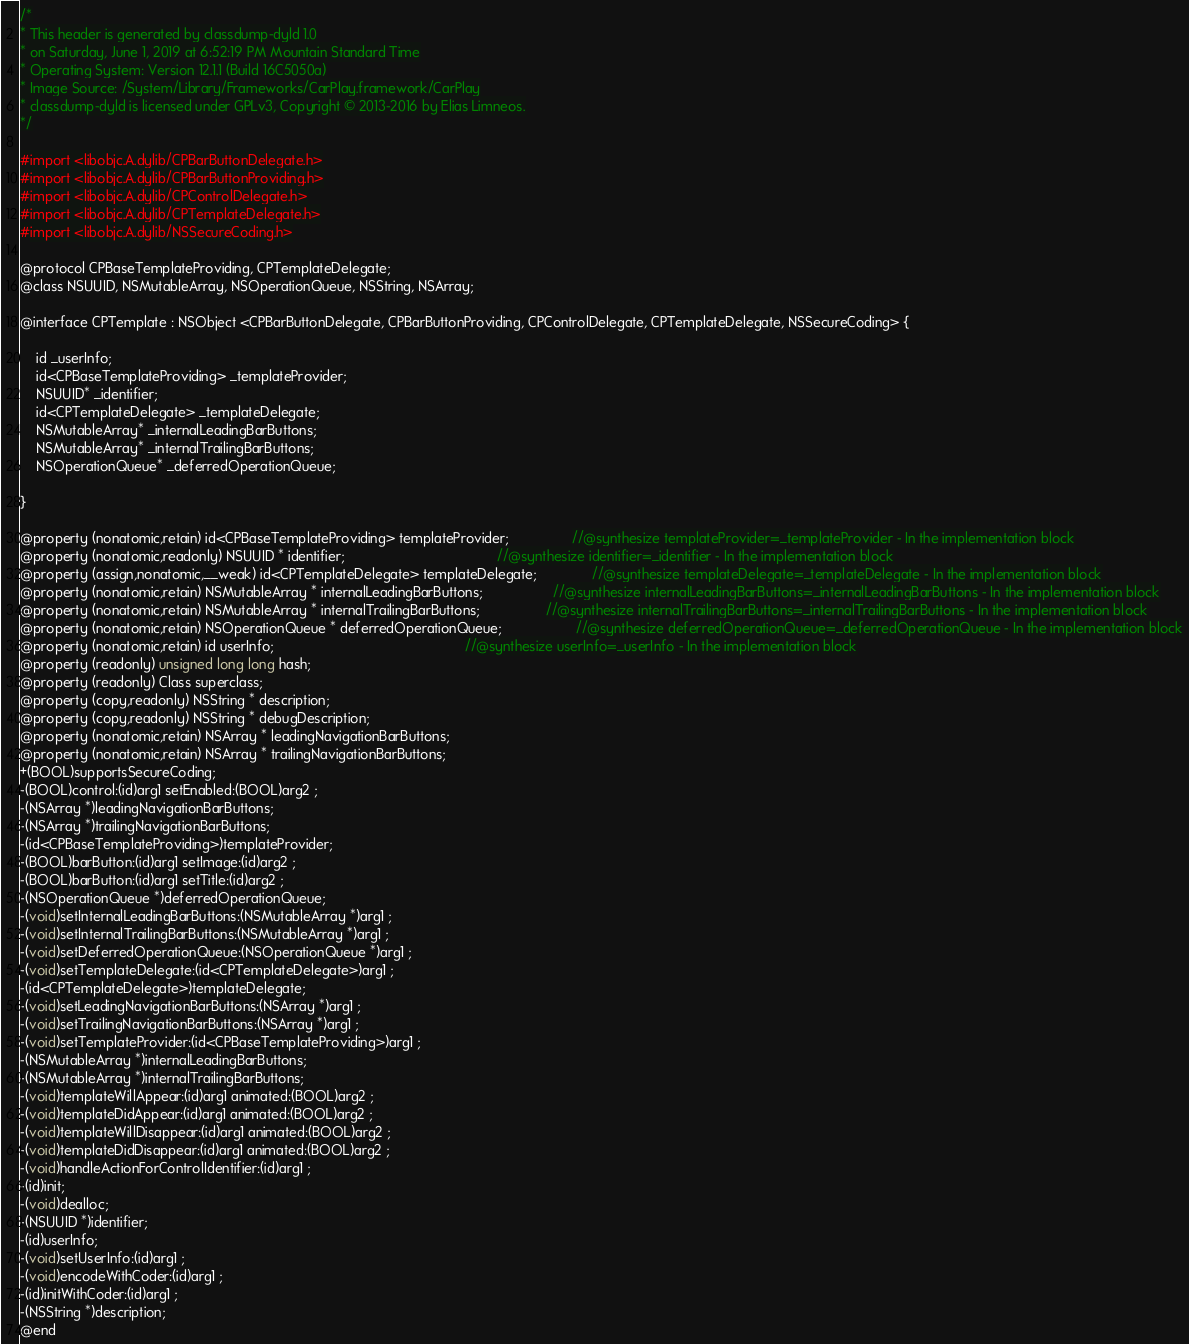Convert code to text. <code><loc_0><loc_0><loc_500><loc_500><_C_>/*
* This header is generated by classdump-dyld 1.0
* on Saturday, June 1, 2019 at 6:52:19 PM Mountain Standard Time
* Operating System: Version 12.1.1 (Build 16C5050a)
* Image Source: /System/Library/Frameworks/CarPlay.framework/CarPlay
* classdump-dyld is licensed under GPLv3, Copyright © 2013-2016 by Elias Limneos.
*/

#import <libobjc.A.dylib/CPBarButtonDelegate.h>
#import <libobjc.A.dylib/CPBarButtonProviding.h>
#import <libobjc.A.dylib/CPControlDelegate.h>
#import <libobjc.A.dylib/CPTemplateDelegate.h>
#import <libobjc.A.dylib/NSSecureCoding.h>

@protocol CPBaseTemplateProviding, CPTemplateDelegate;
@class NSUUID, NSMutableArray, NSOperationQueue, NSString, NSArray;

@interface CPTemplate : NSObject <CPBarButtonDelegate, CPBarButtonProviding, CPControlDelegate, CPTemplateDelegate, NSSecureCoding> {

	id _userInfo;
	id<CPBaseTemplateProviding> _templateProvider;
	NSUUID* _identifier;
	id<CPTemplateDelegate> _templateDelegate;
	NSMutableArray* _internalLeadingBarButtons;
	NSMutableArray* _internalTrailingBarButtons;
	NSOperationQueue* _deferredOperationQueue;

}

@property (nonatomic,retain) id<CPBaseTemplateProviding> templateProvider;                //@synthesize templateProvider=_templateProvider - In the implementation block
@property (nonatomic,readonly) NSUUID * identifier;                                       //@synthesize identifier=_identifier - In the implementation block
@property (assign,nonatomic,__weak) id<CPTemplateDelegate> templateDelegate;              //@synthesize templateDelegate=_templateDelegate - In the implementation block
@property (nonatomic,retain) NSMutableArray * internalLeadingBarButtons;                  //@synthesize internalLeadingBarButtons=_internalLeadingBarButtons - In the implementation block
@property (nonatomic,retain) NSMutableArray * internalTrailingBarButtons;                 //@synthesize internalTrailingBarButtons=_internalTrailingBarButtons - In the implementation block
@property (nonatomic,retain) NSOperationQueue * deferredOperationQueue;                   //@synthesize deferredOperationQueue=_deferredOperationQueue - In the implementation block
@property (nonatomic,retain) id userInfo;                                                 //@synthesize userInfo=_userInfo - In the implementation block
@property (readonly) unsigned long long hash; 
@property (readonly) Class superclass; 
@property (copy,readonly) NSString * description; 
@property (copy,readonly) NSString * debugDescription; 
@property (nonatomic,retain) NSArray * leadingNavigationBarButtons; 
@property (nonatomic,retain) NSArray * trailingNavigationBarButtons; 
+(BOOL)supportsSecureCoding;
-(BOOL)control:(id)arg1 setEnabled:(BOOL)arg2 ;
-(NSArray *)leadingNavigationBarButtons;
-(NSArray *)trailingNavigationBarButtons;
-(id<CPBaseTemplateProviding>)templateProvider;
-(BOOL)barButton:(id)arg1 setImage:(id)arg2 ;
-(BOOL)barButton:(id)arg1 setTitle:(id)arg2 ;
-(NSOperationQueue *)deferredOperationQueue;
-(void)setInternalLeadingBarButtons:(NSMutableArray *)arg1 ;
-(void)setInternalTrailingBarButtons:(NSMutableArray *)arg1 ;
-(void)setDeferredOperationQueue:(NSOperationQueue *)arg1 ;
-(void)setTemplateDelegate:(id<CPTemplateDelegate>)arg1 ;
-(id<CPTemplateDelegate>)templateDelegate;
-(void)setLeadingNavigationBarButtons:(NSArray *)arg1 ;
-(void)setTrailingNavigationBarButtons:(NSArray *)arg1 ;
-(void)setTemplateProvider:(id<CPBaseTemplateProviding>)arg1 ;
-(NSMutableArray *)internalLeadingBarButtons;
-(NSMutableArray *)internalTrailingBarButtons;
-(void)templateWillAppear:(id)arg1 animated:(BOOL)arg2 ;
-(void)templateDidAppear:(id)arg1 animated:(BOOL)arg2 ;
-(void)templateWillDisappear:(id)arg1 animated:(BOOL)arg2 ;
-(void)templateDidDisappear:(id)arg1 animated:(BOOL)arg2 ;
-(void)handleActionForControlIdentifier:(id)arg1 ;
-(id)init;
-(void)dealloc;
-(NSUUID *)identifier;
-(id)userInfo;
-(void)setUserInfo:(id)arg1 ;
-(void)encodeWithCoder:(id)arg1 ;
-(id)initWithCoder:(id)arg1 ;
-(NSString *)description;
@end

</code> 